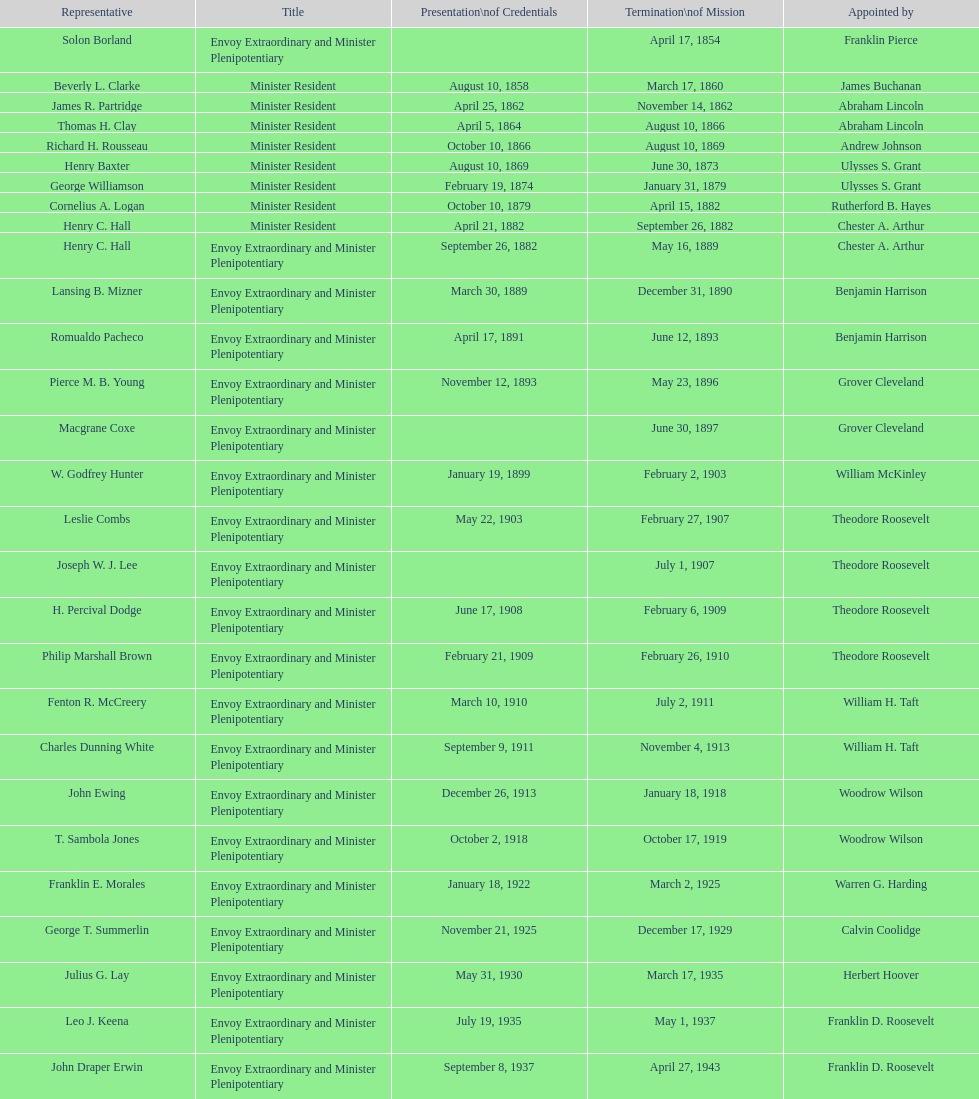Which diplomatic representative to honduras served the most extended term? Henry C. Hall. 